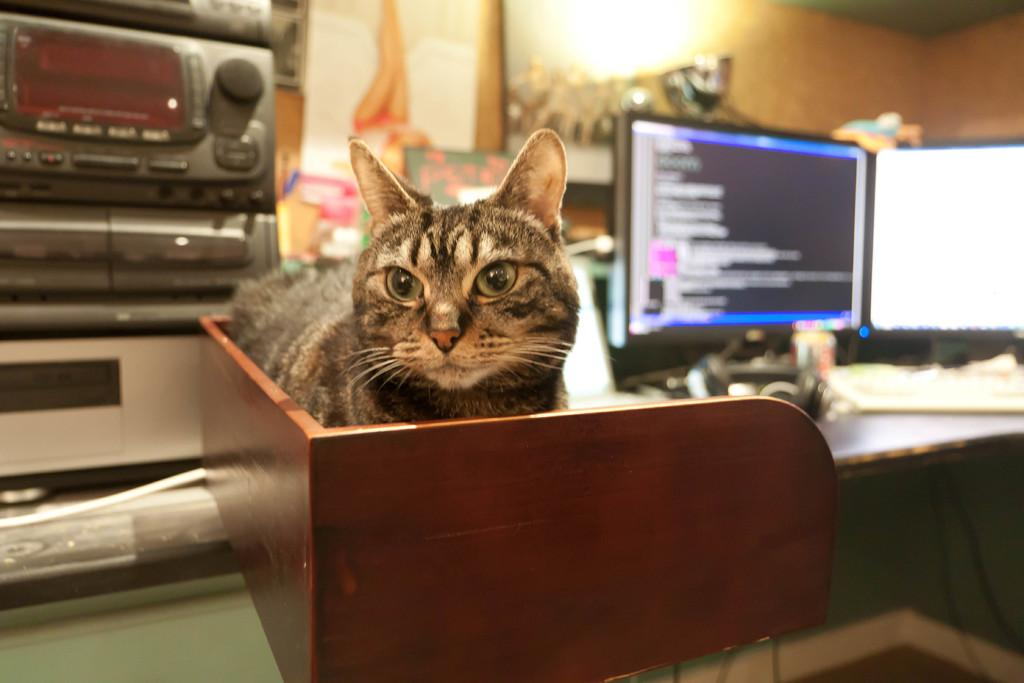What electronic device is visible in the image? There is a laptop in the image. What is the laptop likely being used with? There is a keyboard in the image, which suggests it is being used with the laptop. Are there any animals present in the image? Yes, there is a cat in the image. How many deer can be seen playing with balls in the image? There are no deer or balls present in the image; it features a laptop, a keyboard, and a cat. 